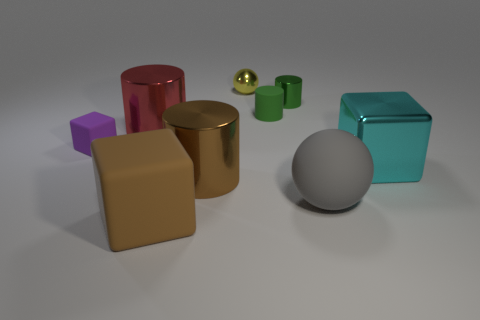Subtract 2 blocks. How many blocks are left? 1 Add 1 small things. How many objects exist? 10 Subtract all red cylinders. How many cylinders are left? 3 Subtract all cylinders. How many objects are left? 5 Subtract all green cylinders. How many cylinders are left? 2 Subtract all brown balls. How many brown cylinders are left? 1 Subtract all large brown metal balls. Subtract all gray matte things. How many objects are left? 8 Add 4 tiny matte cubes. How many tiny matte cubes are left? 5 Add 6 large rubber spheres. How many large rubber spheres exist? 7 Subtract 0 cyan balls. How many objects are left? 9 